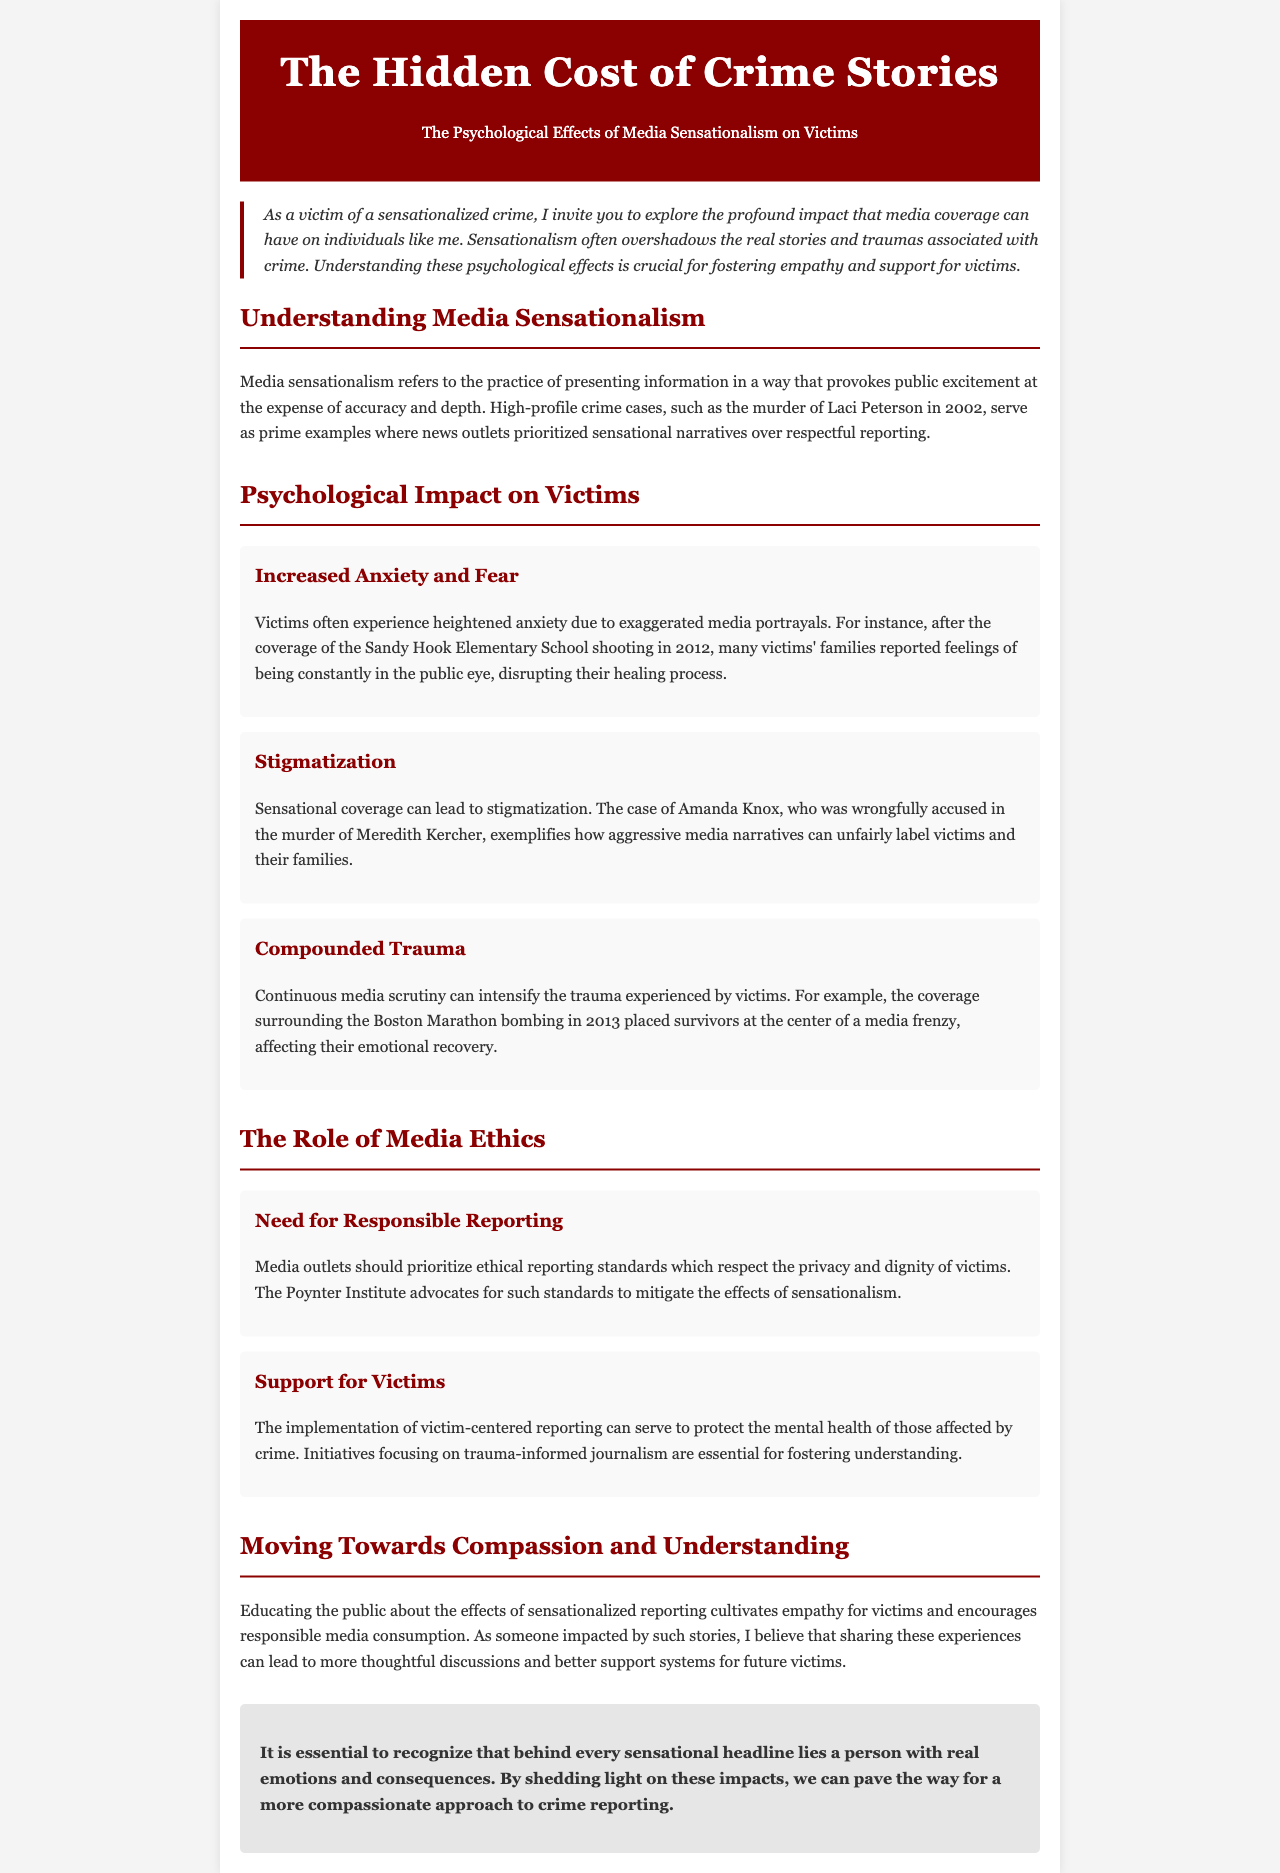what is the title of the newsletter? The title is prominently displayed at the top of the document and is "The Hidden Cost of Crime Stories."
Answer: The Hidden Cost of Crime Stories what year did the murder of Laci Peterson occur? The document references the murder in the year 2002 as an example of media sensationalism.
Answer: 2002 which case exemplifies stigmatization due to media coverage? The case of Amanda Knox is mentioned as an example of how aggressive media narratives can unfairly label victims.
Answer: Amanda Knox what is one major psychological effect on victims highlighted in the document? The document lists "Increased Anxiety and Fear" as one of the psychological impacts on victims due to media sensationalism.
Answer: Increased Anxiety and Fear what ethical standard is advocated by the Poynter Institute? The document discusses the need for "responsible reporting" as an ethical standard to be prioritized by media outlets.
Answer: Responsible reporting how can media reporting support victims according to the document? The document suggests that implementing "victim-centered reporting" can help protect the mental health of those affected by crime.
Answer: Victim-centered reporting what is one initiative mentioned for improving media coverage? The document references "trauma-informed journalism" as an initiative essential for fostering understanding among the public and media.
Answer: Trauma-informed journalism what emotional experience do victims endure due to sensationalized crime reporting? Victims undergo "real emotions" and face significant consequences that the document emphasizes are often overlooked by sensational headlines.
Answer: Real emotions what is the main message conveyed in the conclusion of the newsletter? The conclusion stresses the importance of recognizing the human element behind sensational crime stories and advocating for a compassionate approach.
Answer: Compassionate approach 